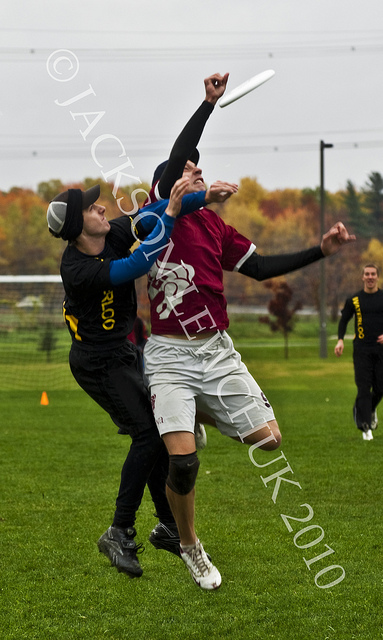Discuss the weather conditions and how they might affect the game shown in the image. The game appears to be taking place under overcast skies, which could indicate cooler temperatures and the potential for rain. Such conditions may affect the game by making the disc slicker and more difficult to catch. Similarly, if the grass is wet, it could influence players' foot traction, affecting their speed and maneuverability. Could this image be used to promote the sport? Despite the watermark, which would need to be addressed, this dynamic image excellently showcases the excitement and athleticism of Ultimate Frisbee. The captured action could indeed be effective in promotional materials to illustrate the sport's energy and competitive nature, appealing to potential new players and spectators. 